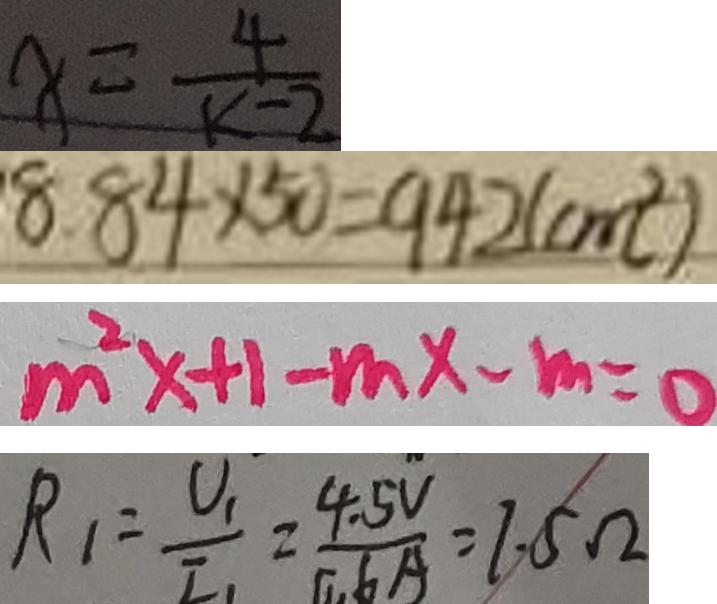<formula> <loc_0><loc_0><loc_500><loc_500>x = \frac { 4 } { k - 2 } 
 8 . 8 4 \times 5 0 = 9 4 2 ( c m ^ { 2 } ) 
 m ^ { 2 } x + 1 - m x - m = 0 
 R _ { 1 } = \frac { U _ { 1 } } { I _ { 1 } } = \frac { 4 . 5 V } { 0 . 6 A } = 7 . 5 \Omega</formula> 